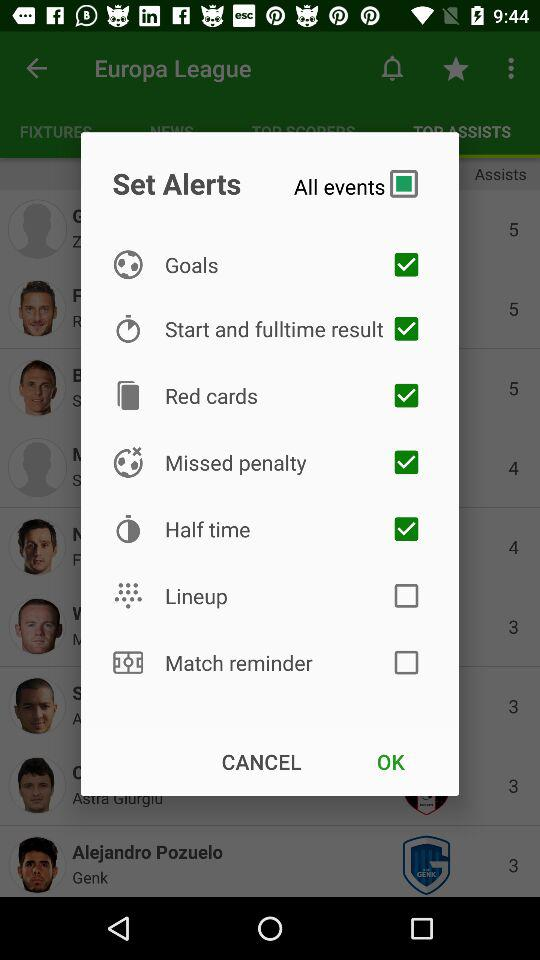What events are there to set an alert for? The events are goals, start and fulltime result, red cards, missed penalty, half time, lineup and match reminder. 